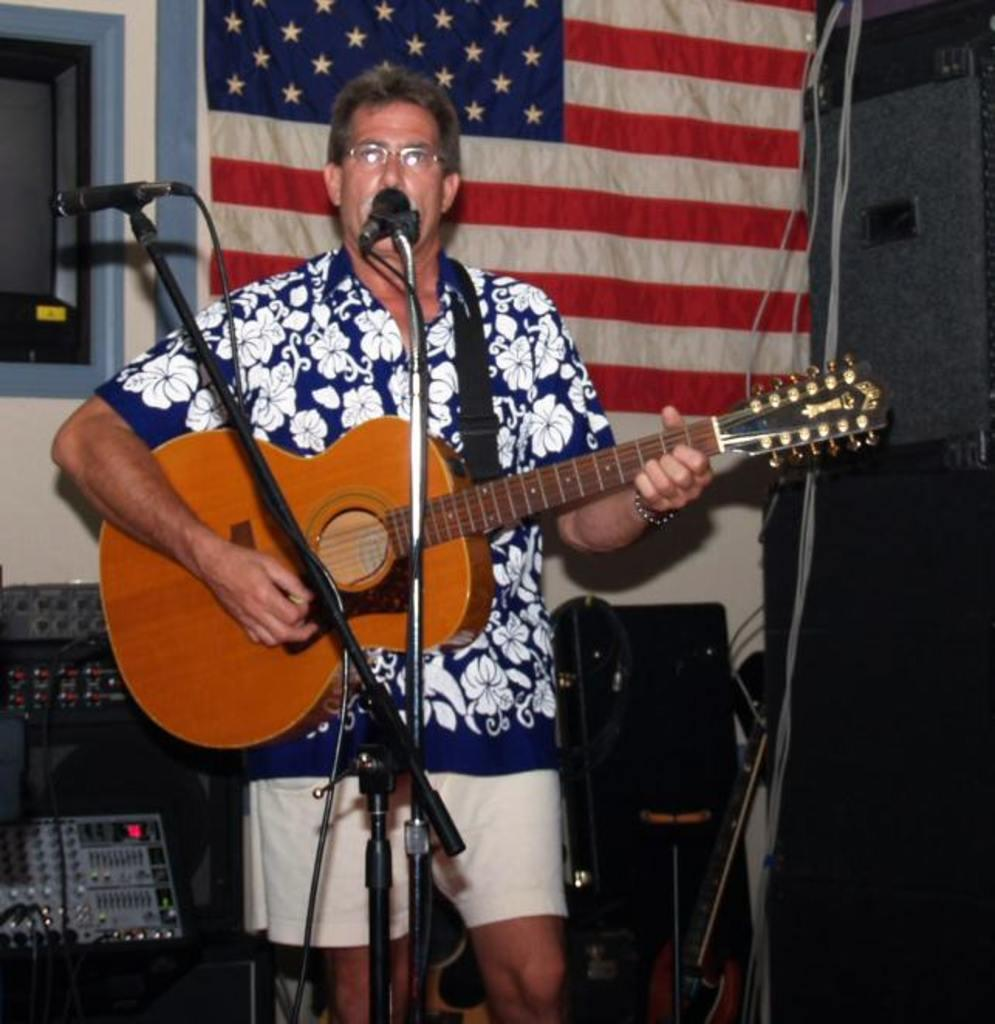Who is the main subject in the image? A: There is an old man in the image. What is the old man wearing? The old man is wearing a flower shirt. What is the old man doing in the image? The old man is playing a guitar and singing on a microphone. What can be seen in the background of the image? There is an amplifier in the background of the image. What architectural feature is present in the image? There is a window in the left side corner of the image. What type of quiver is the old man using to hold his letters in the image? There is no quiver or letters present in the image. What advice does the old man's mother give him in the image? There is no mention of the old man's mother in the image. 